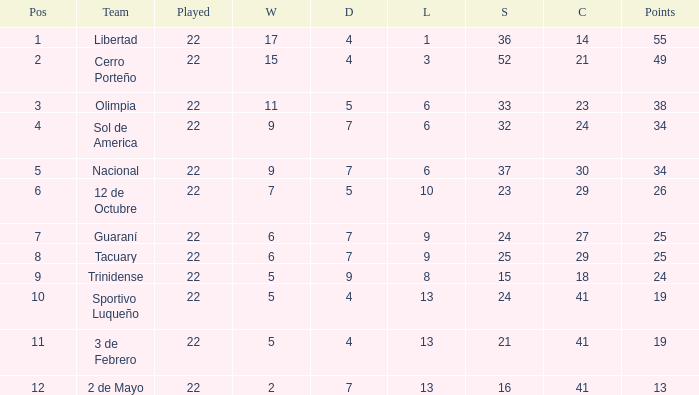What is the fewest wins that has fewer than 23 goals scored, team of 2 de Mayo, and fewer than 7 draws? None. 